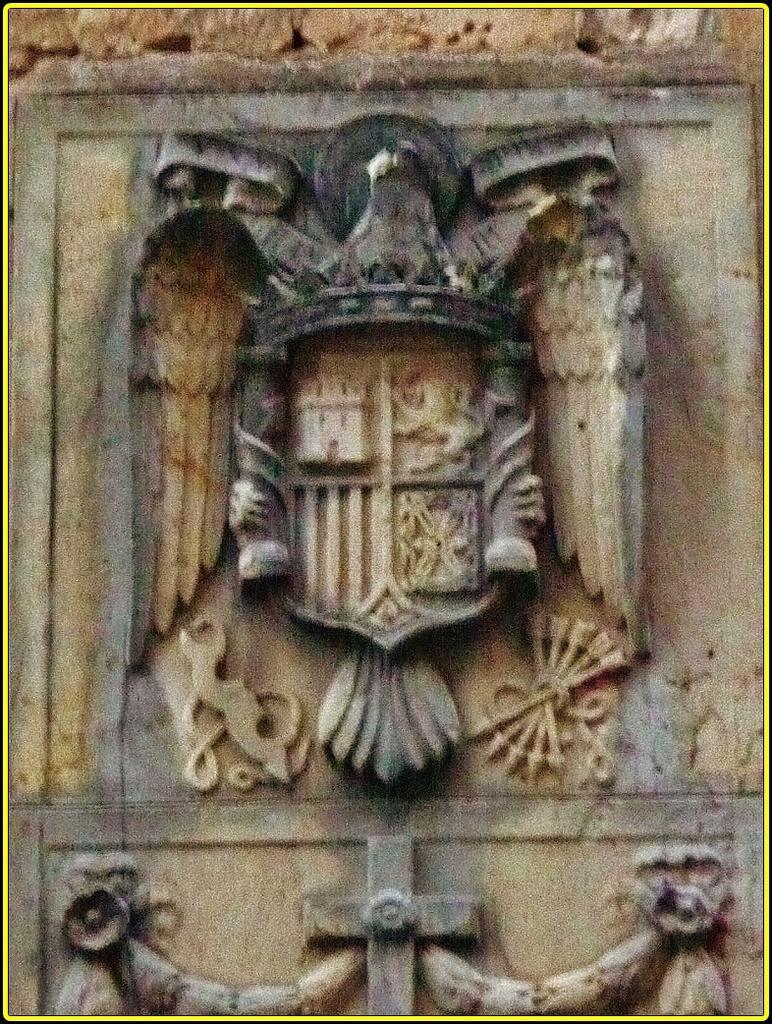Could you give a brief overview of what you see in this image? In this image there is a sculpture. 